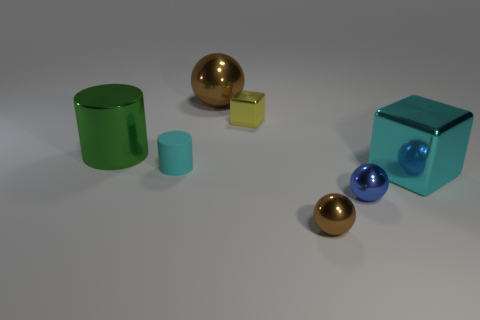There is a object that is the same color as the large block; what is its shape?
Give a very brief answer. Cylinder. Is there anything else that has the same material as the small cylinder?
Give a very brief answer. No. There is a big thing that is on the right side of the rubber cylinder and behind the cyan metallic thing; what is its material?
Ensure brevity in your answer.  Metal. There is a shiny block behind the green cylinder; is it the same size as the small blue sphere?
Offer a very short reply. Yes. Is the color of the small matte thing the same as the big metallic cube?
Give a very brief answer. Yes. How many spheres are both on the right side of the yellow shiny cube and behind the tiny cyan rubber thing?
Offer a very short reply. 0. How many yellow blocks are behind the cyan object right of the brown thing that is left of the small yellow shiny block?
Make the answer very short. 1. There is a object that is the same color as the big shiny cube; what size is it?
Your response must be concise. Small. There is a large green thing; what shape is it?
Your answer should be very brief. Cylinder. What number of other tiny brown objects are the same material as the tiny brown thing?
Offer a terse response. 0. 